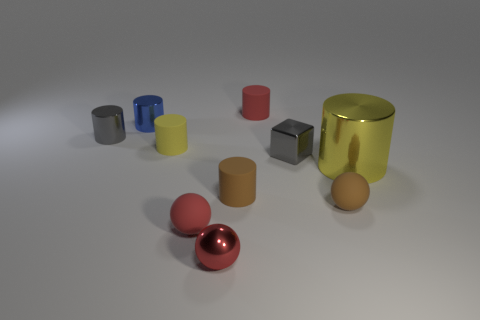Subtract all blue cylinders. How many cylinders are left? 5 Subtract all brown matte cylinders. How many cylinders are left? 5 Subtract all green cylinders. Subtract all purple blocks. How many cylinders are left? 6 Subtract all spheres. How many objects are left? 7 Subtract 0 purple spheres. How many objects are left? 10 Subtract all brown metallic spheres. Subtract all big cylinders. How many objects are left? 9 Add 6 yellow rubber objects. How many yellow rubber objects are left? 7 Add 8 tiny brown matte cubes. How many tiny brown matte cubes exist? 8 